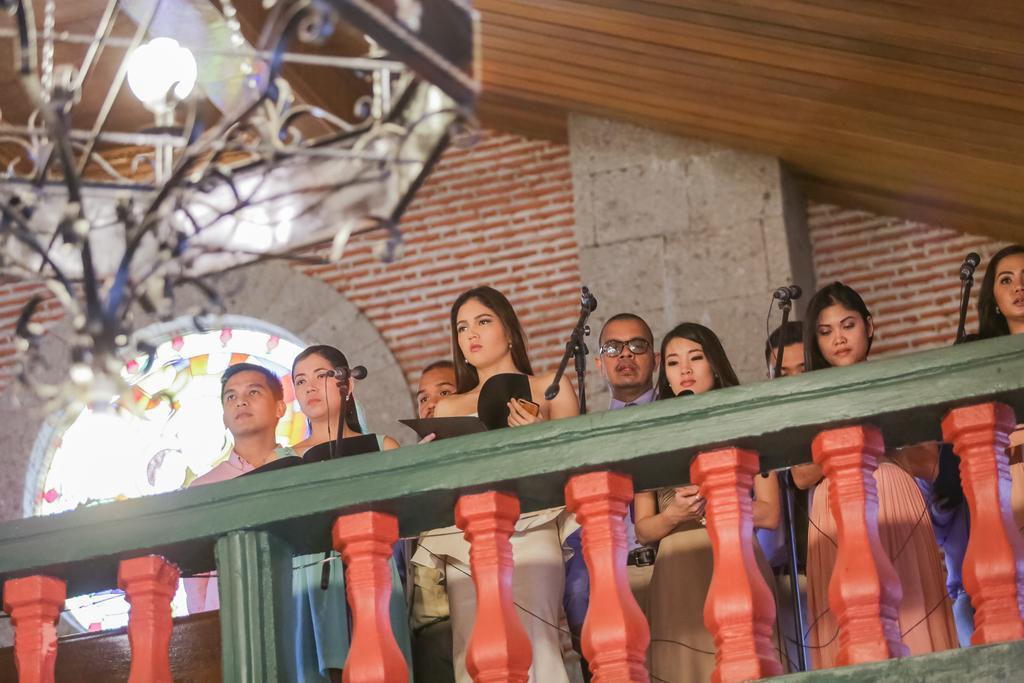Can you describe this image briefly? In this image in the front there is a railing which is green and red in colour. In the center there are persons standing and there are mic stands. In the background there is a wall and there is a window. On the top there is a chandelier which is visible. 